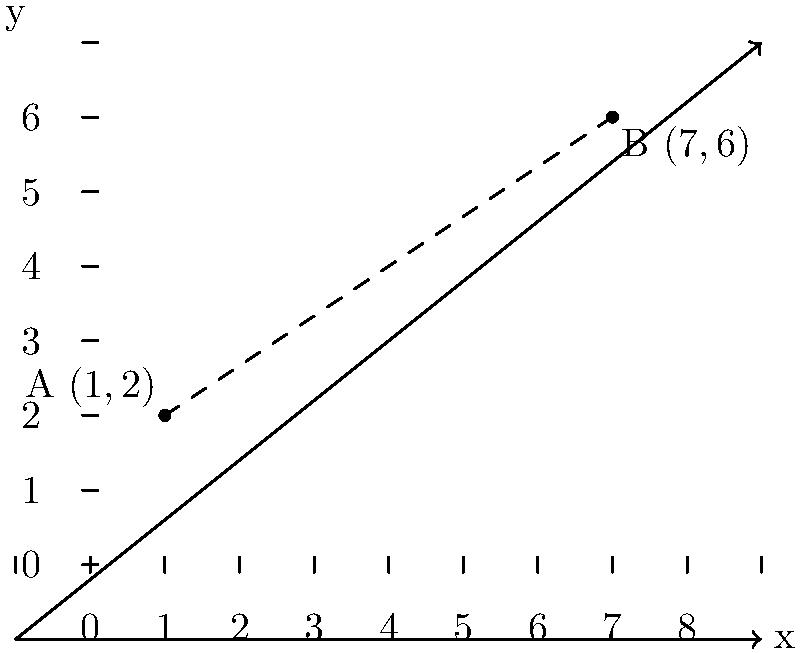As the community leader addressing public safety, you're tasked with analyzing the placement of two emergency response centers in your town. The centers are located at points A(1,2) and B(7,6) on a coordinate plane where each unit represents 1 mile. What is the straight-line distance between these two centers? Round your answer to the nearest tenth of a mile. To find the distance between two points on a coordinate plane, we can use the distance formula:

$$ d = \sqrt{(x_2 - x_1)^2 + (y_2 - y_1)^2} $$

Where $(x_1, y_1)$ are the coordinates of the first point and $(x_2, y_2)$ are the coordinates of the second point.

Let's plug in our values:
* Point A: $(x_1, y_1) = (1, 2)$
* Point B: $(x_2, y_2) = (7, 6)$

$$ d = \sqrt{(7 - 1)^2 + (6 - 2)^2} $$

$$ d = \sqrt{6^2 + 4^2} $$

$$ d = \sqrt{36 + 16} $$

$$ d = \sqrt{52} $$

$$ d \approx 7.211102551 $$

Rounding to the nearest tenth:

$$ d \approx 7.2 \text{ miles} $$

This distance represents the straight-line distance between the two emergency response centers.
Answer: 7.2 miles 